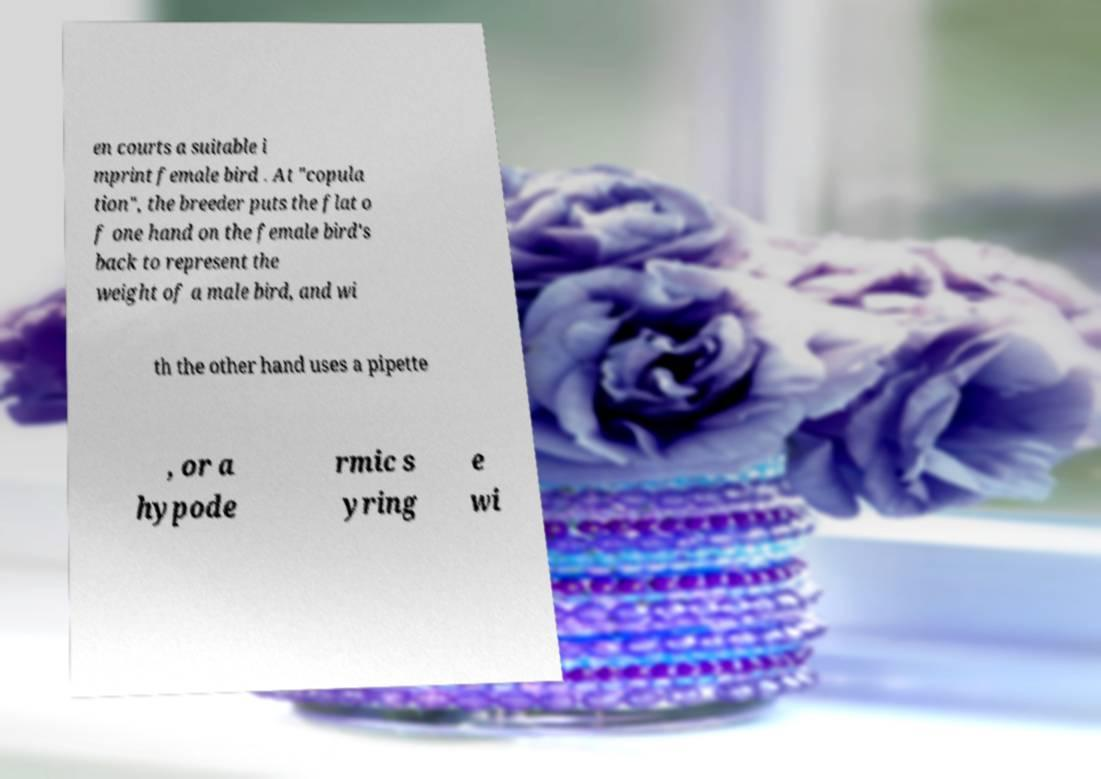Could you extract and type out the text from this image? en courts a suitable i mprint female bird . At "copula tion", the breeder puts the flat o f one hand on the female bird's back to represent the weight of a male bird, and wi th the other hand uses a pipette , or a hypode rmic s yring e wi 